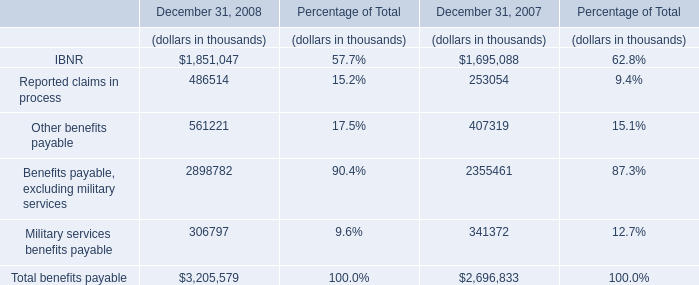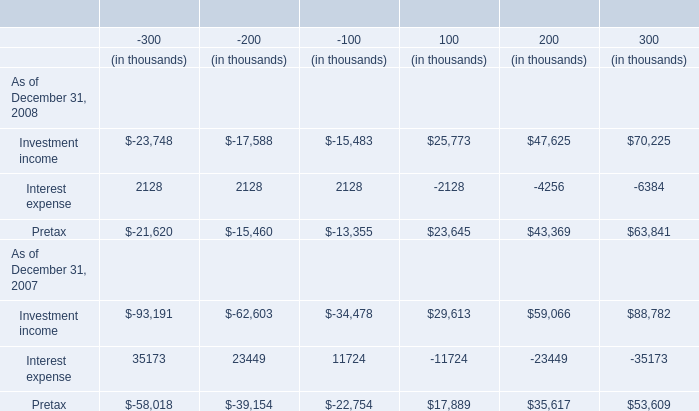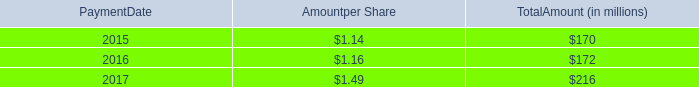In the year with the most Pretax, what is the growth rate of Interest expense? 
Computations: (((((((2128 + 2128) + 2128) - 2128) - 4256) - 6384) - (((((35173 + 23449) + 11724) - 11724) - 23449) - 35173)) / (((((2128 + 2128) + 2128) - 2128) - 4256) - 6384))
Answer: 1.0. 